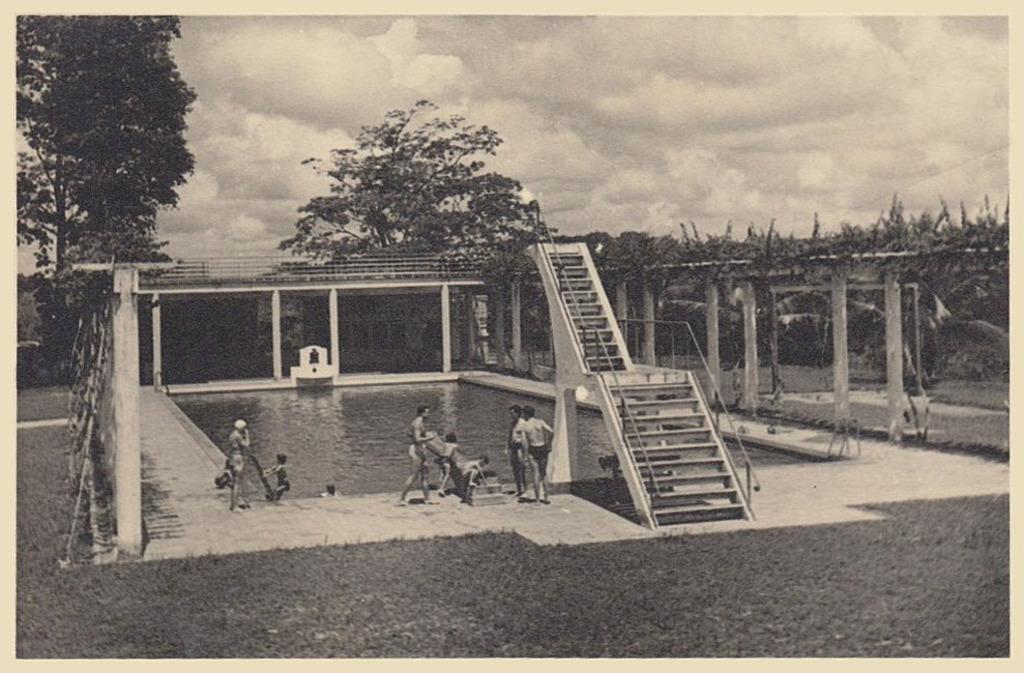What is the color scheme of the image? The image is black and white. Who or what can be seen in the image? There are persons in the image. What architectural feature is present in the image? There are stairs and pillars in the image. What natural elements can be seen in the image? There is water, grass, trees, and sky visible in the image. What is the weather like in the image? The sky has clouds, indicating that it might be a partly cloudy day. What type of pain is being expressed by the wool in the image? There is no wool or pain present in the image; it features black and white elements such as persons, stairs, pillars, water, grass, trees, and sky. 